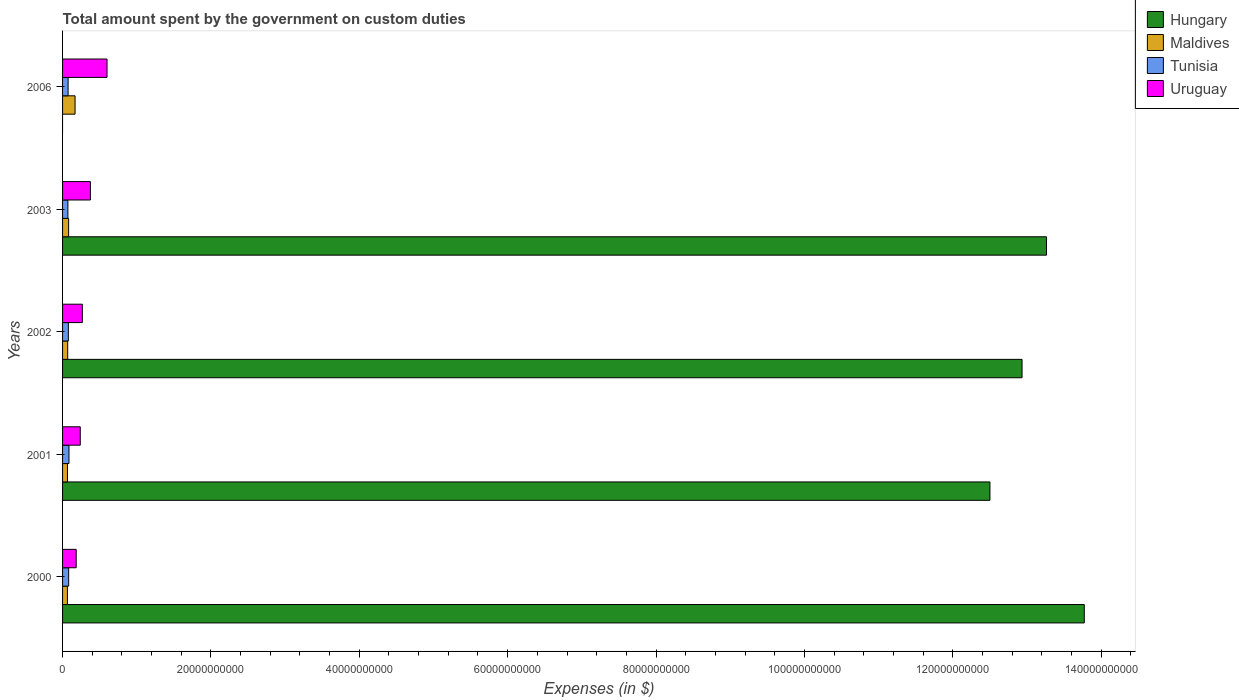How many groups of bars are there?
Keep it short and to the point. 5. How many bars are there on the 3rd tick from the top?
Ensure brevity in your answer.  4. How many bars are there on the 5th tick from the bottom?
Keep it short and to the point. 3. What is the amount spent on custom duties by the government in Hungary in 2000?
Your response must be concise. 1.38e+11. Across all years, what is the maximum amount spent on custom duties by the government in Uruguay?
Make the answer very short. 5.99e+09. Across all years, what is the minimum amount spent on custom duties by the government in Tunisia?
Make the answer very short. 7.17e+08. What is the total amount spent on custom duties by the government in Maldives in the graph?
Make the answer very short. 4.51e+09. What is the difference between the amount spent on custom duties by the government in Hungary in 2000 and that in 2002?
Your answer should be compact. 8.39e+09. What is the difference between the amount spent on custom duties by the government in Hungary in 2001 and the amount spent on custom duties by the government in Tunisia in 2002?
Make the answer very short. 1.24e+11. What is the average amount spent on custom duties by the government in Hungary per year?
Provide a succinct answer. 1.05e+11. In the year 2002, what is the difference between the amount spent on custom duties by the government in Hungary and amount spent on custom duties by the government in Maldives?
Make the answer very short. 1.29e+11. In how many years, is the amount spent on custom duties by the government in Hungary greater than 104000000000 $?
Offer a very short reply. 4. What is the ratio of the amount spent on custom duties by the government in Uruguay in 2001 to that in 2006?
Offer a terse response. 0.4. Is the amount spent on custom duties by the government in Hungary in 2000 less than that in 2003?
Your answer should be very brief. No. What is the difference between the highest and the second highest amount spent on custom duties by the government in Maldives?
Your answer should be very brief. 8.67e+08. What is the difference between the highest and the lowest amount spent on custom duties by the government in Hungary?
Offer a terse response. 1.38e+11. In how many years, is the amount spent on custom duties by the government in Maldives greater than the average amount spent on custom duties by the government in Maldives taken over all years?
Provide a succinct answer. 1. Is it the case that in every year, the sum of the amount spent on custom duties by the government in Maldives and amount spent on custom duties by the government in Uruguay is greater than the amount spent on custom duties by the government in Hungary?
Your response must be concise. No. How many bars are there?
Keep it short and to the point. 19. How many years are there in the graph?
Make the answer very short. 5. What is the title of the graph?
Offer a terse response. Total amount spent by the government on custom duties. Does "Caribbean small states" appear as one of the legend labels in the graph?
Give a very brief answer. No. What is the label or title of the X-axis?
Give a very brief answer. Expenses (in $). What is the label or title of the Y-axis?
Offer a terse response. Years. What is the Expenses (in $) of Hungary in 2000?
Provide a short and direct response. 1.38e+11. What is the Expenses (in $) of Maldives in 2000?
Your answer should be very brief. 6.53e+08. What is the Expenses (in $) of Tunisia in 2000?
Provide a short and direct response. 8.22e+08. What is the Expenses (in $) in Uruguay in 2000?
Give a very brief answer. 1.84e+09. What is the Expenses (in $) in Hungary in 2001?
Provide a succinct answer. 1.25e+11. What is the Expenses (in $) of Maldives in 2001?
Offer a terse response. 6.62e+08. What is the Expenses (in $) of Tunisia in 2001?
Offer a terse response. 8.66e+08. What is the Expenses (in $) in Uruguay in 2001?
Provide a short and direct response. 2.38e+09. What is the Expenses (in $) in Hungary in 2002?
Make the answer very short. 1.29e+11. What is the Expenses (in $) of Maldives in 2002?
Give a very brief answer. 6.92e+08. What is the Expenses (in $) in Tunisia in 2002?
Ensure brevity in your answer.  7.81e+08. What is the Expenses (in $) of Uruguay in 2002?
Your answer should be compact. 2.67e+09. What is the Expenses (in $) in Hungary in 2003?
Offer a terse response. 1.33e+11. What is the Expenses (in $) in Maldives in 2003?
Provide a short and direct response. 8.17e+08. What is the Expenses (in $) in Tunisia in 2003?
Provide a succinct answer. 7.17e+08. What is the Expenses (in $) in Uruguay in 2003?
Give a very brief answer. 3.75e+09. What is the Expenses (in $) in Maldives in 2006?
Your answer should be compact. 1.68e+09. What is the Expenses (in $) in Tunisia in 2006?
Your answer should be compact. 7.47e+08. What is the Expenses (in $) in Uruguay in 2006?
Provide a succinct answer. 5.99e+09. Across all years, what is the maximum Expenses (in $) of Hungary?
Your answer should be compact. 1.38e+11. Across all years, what is the maximum Expenses (in $) in Maldives?
Ensure brevity in your answer.  1.68e+09. Across all years, what is the maximum Expenses (in $) of Tunisia?
Provide a short and direct response. 8.66e+08. Across all years, what is the maximum Expenses (in $) of Uruguay?
Your answer should be compact. 5.99e+09. Across all years, what is the minimum Expenses (in $) of Maldives?
Ensure brevity in your answer.  6.53e+08. Across all years, what is the minimum Expenses (in $) in Tunisia?
Keep it short and to the point. 7.17e+08. Across all years, what is the minimum Expenses (in $) of Uruguay?
Your answer should be very brief. 1.84e+09. What is the total Expenses (in $) in Hungary in the graph?
Your answer should be compact. 5.25e+11. What is the total Expenses (in $) in Maldives in the graph?
Your answer should be very brief. 4.51e+09. What is the total Expenses (in $) of Tunisia in the graph?
Give a very brief answer. 3.93e+09. What is the total Expenses (in $) in Uruguay in the graph?
Your response must be concise. 1.66e+1. What is the difference between the Expenses (in $) in Hungary in 2000 and that in 2001?
Ensure brevity in your answer.  1.27e+1. What is the difference between the Expenses (in $) in Maldives in 2000 and that in 2001?
Give a very brief answer. -9.10e+06. What is the difference between the Expenses (in $) of Tunisia in 2000 and that in 2001?
Offer a very short reply. -4.38e+07. What is the difference between the Expenses (in $) of Uruguay in 2000 and that in 2001?
Make the answer very short. -5.47e+08. What is the difference between the Expenses (in $) in Hungary in 2000 and that in 2002?
Provide a succinct answer. 8.39e+09. What is the difference between the Expenses (in $) in Maldives in 2000 and that in 2002?
Offer a terse response. -3.95e+07. What is the difference between the Expenses (in $) in Tunisia in 2000 and that in 2002?
Ensure brevity in your answer.  4.11e+07. What is the difference between the Expenses (in $) in Uruguay in 2000 and that in 2002?
Offer a terse response. -8.29e+08. What is the difference between the Expenses (in $) in Hungary in 2000 and that in 2003?
Offer a very short reply. 5.09e+09. What is the difference between the Expenses (in $) of Maldives in 2000 and that in 2003?
Offer a terse response. -1.64e+08. What is the difference between the Expenses (in $) in Tunisia in 2000 and that in 2003?
Provide a succinct answer. 1.05e+08. What is the difference between the Expenses (in $) in Uruguay in 2000 and that in 2003?
Offer a very short reply. -1.92e+09. What is the difference between the Expenses (in $) in Maldives in 2000 and that in 2006?
Your answer should be very brief. -1.03e+09. What is the difference between the Expenses (in $) of Tunisia in 2000 and that in 2006?
Give a very brief answer. 7.54e+07. What is the difference between the Expenses (in $) in Uruguay in 2000 and that in 2006?
Offer a very short reply. -4.16e+09. What is the difference between the Expenses (in $) of Hungary in 2001 and that in 2002?
Offer a very short reply. -4.33e+09. What is the difference between the Expenses (in $) in Maldives in 2001 and that in 2002?
Your answer should be compact. -3.04e+07. What is the difference between the Expenses (in $) of Tunisia in 2001 and that in 2002?
Your response must be concise. 8.49e+07. What is the difference between the Expenses (in $) of Uruguay in 2001 and that in 2002?
Ensure brevity in your answer.  -2.82e+08. What is the difference between the Expenses (in $) of Hungary in 2001 and that in 2003?
Make the answer very short. -7.62e+09. What is the difference between the Expenses (in $) of Maldives in 2001 and that in 2003?
Offer a very short reply. -1.55e+08. What is the difference between the Expenses (in $) of Tunisia in 2001 and that in 2003?
Offer a terse response. 1.49e+08. What is the difference between the Expenses (in $) in Uruguay in 2001 and that in 2003?
Offer a very short reply. -1.37e+09. What is the difference between the Expenses (in $) in Maldives in 2001 and that in 2006?
Your response must be concise. -1.02e+09. What is the difference between the Expenses (in $) of Tunisia in 2001 and that in 2006?
Provide a short and direct response. 1.19e+08. What is the difference between the Expenses (in $) in Uruguay in 2001 and that in 2006?
Offer a terse response. -3.61e+09. What is the difference between the Expenses (in $) of Hungary in 2002 and that in 2003?
Your answer should be compact. -3.30e+09. What is the difference between the Expenses (in $) of Maldives in 2002 and that in 2003?
Give a very brief answer. -1.25e+08. What is the difference between the Expenses (in $) of Tunisia in 2002 and that in 2003?
Provide a short and direct response. 6.41e+07. What is the difference between the Expenses (in $) of Uruguay in 2002 and that in 2003?
Ensure brevity in your answer.  -1.09e+09. What is the difference between the Expenses (in $) of Maldives in 2002 and that in 2006?
Your answer should be compact. -9.92e+08. What is the difference between the Expenses (in $) in Tunisia in 2002 and that in 2006?
Your answer should be very brief. 3.43e+07. What is the difference between the Expenses (in $) of Uruguay in 2002 and that in 2006?
Offer a very short reply. -3.33e+09. What is the difference between the Expenses (in $) in Maldives in 2003 and that in 2006?
Provide a short and direct response. -8.67e+08. What is the difference between the Expenses (in $) in Tunisia in 2003 and that in 2006?
Ensure brevity in your answer.  -2.98e+07. What is the difference between the Expenses (in $) of Uruguay in 2003 and that in 2006?
Provide a succinct answer. -2.24e+09. What is the difference between the Expenses (in $) of Hungary in 2000 and the Expenses (in $) of Maldives in 2001?
Provide a succinct answer. 1.37e+11. What is the difference between the Expenses (in $) in Hungary in 2000 and the Expenses (in $) in Tunisia in 2001?
Give a very brief answer. 1.37e+11. What is the difference between the Expenses (in $) in Hungary in 2000 and the Expenses (in $) in Uruguay in 2001?
Offer a terse response. 1.35e+11. What is the difference between the Expenses (in $) of Maldives in 2000 and the Expenses (in $) of Tunisia in 2001?
Keep it short and to the point. -2.14e+08. What is the difference between the Expenses (in $) of Maldives in 2000 and the Expenses (in $) of Uruguay in 2001?
Your answer should be very brief. -1.73e+09. What is the difference between the Expenses (in $) of Tunisia in 2000 and the Expenses (in $) of Uruguay in 2001?
Offer a very short reply. -1.56e+09. What is the difference between the Expenses (in $) of Hungary in 2000 and the Expenses (in $) of Maldives in 2002?
Your answer should be compact. 1.37e+11. What is the difference between the Expenses (in $) of Hungary in 2000 and the Expenses (in $) of Tunisia in 2002?
Your answer should be compact. 1.37e+11. What is the difference between the Expenses (in $) of Hungary in 2000 and the Expenses (in $) of Uruguay in 2002?
Offer a terse response. 1.35e+11. What is the difference between the Expenses (in $) of Maldives in 2000 and the Expenses (in $) of Tunisia in 2002?
Offer a very short reply. -1.29e+08. What is the difference between the Expenses (in $) in Maldives in 2000 and the Expenses (in $) in Uruguay in 2002?
Offer a terse response. -2.01e+09. What is the difference between the Expenses (in $) in Tunisia in 2000 and the Expenses (in $) in Uruguay in 2002?
Provide a short and direct response. -1.84e+09. What is the difference between the Expenses (in $) in Hungary in 2000 and the Expenses (in $) in Maldives in 2003?
Your answer should be very brief. 1.37e+11. What is the difference between the Expenses (in $) in Hungary in 2000 and the Expenses (in $) in Tunisia in 2003?
Your answer should be compact. 1.37e+11. What is the difference between the Expenses (in $) in Hungary in 2000 and the Expenses (in $) in Uruguay in 2003?
Provide a short and direct response. 1.34e+11. What is the difference between the Expenses (in $) of Maldives in 2000 and the Expenses (in $) of Tunisia in 2003?
Give a very brief answer. -6.46e+07. What is the difference between the Expenses (in $) in Maldives in 2000 and the Expenses (in $) in Uruguay in 2003?
Your answer should be compact. -3.10e+09. What is the difference between the Expenses (in $) in Tunisia in 2000 and the Expenses (in $) in Uruguay in 2003?
Give a very brief answer. -2.93e+09. What is the difference between the Expenses (in $) of Hungary in 2000 and the Expenses (in $) of Maldives in 2006?
Your answer should be very brief. 1.36e+11. What is the difference between the Expenses (in $) in Hungary in 2000 and the Expenses (in $) in Tunisia in 2006?
Your answer should be very brief. 1.37e+11. What is the difference between the Expenses (in $) in Hungary in 2000 and the Expenses (in $) in Uruguay in 2006?
Make the answer very short. 1.32e+11. What is the difference between the Expenses (in $) of Maldives in 2000 and the Expenses (in $) of Tunisia in 2006?
Give a very brief answer. -9.44e+07. What is the difference between the Expenses (in $) of Maldives in 2000 and the Expenses (in $) of Uruguay in 2006?
Make the answer very short. -5.34e+09. What is the difference between the Expenses (in $) in Tunisia in 2000 and the Expenses (in $) in Uruguay in 2006?
Your response must be concise. -5.17e+09. What is the difference between the Expenses (in $) of Hungary in 2001 and the Expenses (in $) of Maldives in 2002?
Your answer should be very brief. 1.24e+11. What is the difference between the Expenses (in $) of Hungary in 2001 and the Expenses (in $) of Tunisia in 2002?
Give a very brief answer. 1.24e+11. What is the difference between the Expenses (in $) of Hungary in 2001 and the Expenses (in $) of Uruguay in 2002?
Ensure brevity in your answer.  1.22e+11. What is the difference between the Expenses (in $) in Maldives in 2001 and the Expenses (in $) in Tunisia in 2002?
Your answer should be compact. -1.20e+08. What is the difference between the Expenses (in $) in Maldives in 2001 and the Expenses (in $) in Uruguay in 2002?
Your response must be concise. -2.01e+09. What is the difference between the Expenses (in $) of Tunisia in 2001 and the Expenses (in $) of Uruguay in 2002?
Your response must be concise. -1.80e+09. What is the difference between the Expenses (in $) of Hungary in 2001 and the Expenses (in $) of Maldives in 2003?
Provide a succinct answer. 1.24e+11. What is the difference between the Expenses (in $) of Hungary in 2001 and the Expenses (in $) of Tunisia in 2003?
Provide a succinct answer. 1.24e+11. What is the difference between the Expenses (in $) of Hungary in 2001 and the Expenses (in $) of Uruguay in 2003?
Keep it short and to the point. 1.21e+11. What is the difference between the Expenses (in $) of Maldives in 2001 and the Expenses (in $) of Tunisia in 2003?
Provide a short and direct response. -5.55e+07. What is the difference between the Expenses (in $) of Maldives in 2001 and the Expenses (in $) of Uruguay in 2003?
Your answer should be compact. -3.09e+09. What is the difference between the Expenses (in $) in Tunisia in 2001 and the Expenses (in $) in Uruguay in 2003?
Keep it short and to the point. -2.89e+09. What is the difference between the Expenses (in $) in Hungary in 2001 and the Expenses (in $) in Maldives in 2006?
Give a very brief answer. 1.23e+11. What is the difference between the Expenses (in $) in Hungary in 2001 and the Expenses (in $) in Tunisia in 2006?
Keep it short and to the point. 1.24e+11. What is the difference between the Expenses (in $) in Hungary in 2001 and the Expenses (in $) in Uruguay in 2006?
Offer a very short reply. 1.19e+11. What is the difference between the Expenses (in $) in Maldives in 2001 and the Expenses (in $) in Tunisia in 2006?
Offer a terse response. -8.53e+07. What is the difference between the Expenses (in $) of Maldives in 2001 and the Expenses (in $) of Uruguay in 2006?
Provide a succinct answer. -5.33e+09. What is the difference between the Expenses (in $) of Tunisia in 2001 and the Expenses (in $) of Uruguay in 2006?
Make the answer very short. -5.13e+09. What is the difference between the Expenses (in $) of Hungary in 2002 and the Expenses (in $) of Maldives in 2003?
Offer a very short reply. 1.29e+11. What is the difference between the Expenses (in $) in Hungary in 2002 and the Expenses (in $) in Tunisia in 2003?
Give a very brief answer. 1.29e+11. What is the difference between the Expenses (in $) in Hungary in 2002 and the Expenses (in $) in Uruguay in 2003?
Give a very brief answer. 1.26e+11. What is the difference between the Expenses (in $) in Maldives in 2002 and the Expenses (in $) in Tunisia in 2003?
Ensure brevity in your answer.  -2.51e+07. What is the difference between the Expenses (in $) in Maldives in 2002 and the Expenses (in $) in Uruguay in 2003?
Offer a terse response. -3.06e+09. What is the difference between the Expenses (in $) of Tunisia in 2002 and the Expenses (in $) of Uruguay in 2003?
Your response must be concise. -2.97e+09. What is the difference between the Expenses (in $) in Hungary in 2002 and the Expenses (in $) in Maldives in 2006?
Your response must be concise. 1.28e+11. What is the difference between the Expenses (in $) of Hungary in 2002 and the Expenses (in $) of Tunisia in 2006?
Give a very brief answer. 1.29e+11. What is the difference between the Expenses (in $) in Hungary in 2002 and the Expenses (in $) in Uruguay in 2006?
Your answer should be very brief. 1.23e+11. What is the difference between the Expenses (in $) in Maldives in 2002 and the Expenses (in $) in Tunisia in 2006?
Make the answer very short. -5.49e+07. What is the difference between the Expenses (in $) of Maldives in 2002 and the Expenses (in $) of Uruguay in 2006?
Your answer should be compact. -5.30e+09. What is the difference between the Expenses (in $) of Tunisia in 2002 and the Expenses (in $) of Uruguay in 2006?
Your answer should be very brief. -5.21e+09. What is the difference between the Expenses (in $) of Hungary in 2003 and the Expenses (in $) of Maldives in 2006?
Give a very brief answer. 1.31e+11. What is the difference between the Expenses (in $) in Hungary in 2003 and the Expenses (in $) in Tunisia in 2006?
Your response must be concise. 1.32e+11. What is the difference between the Expenses (in $) in Hungary in 2003 and the Expenses (in $) in Uruguay in 2006?
Give a very brief answer. 1.27e+11. What is the difference between the Expenses (in $) of Maldives in 2003 and the Expenses (in $) of Tunisia in 2006?
Provide a short and direct response. 7.01e+07. What is the difference between the Expenses (in $) of Maldives in 2003 and the Expenses (in $) of Uruguay in 2006?
Offer a very short reply. -5.18e+09. What is the difference between the Expenses (in $) of Tunisia in 2003 and the Expenses (in $) of Uruguay in 2006?
Your response must be concise. -5.28e+09. What is the average Expenses (in $) of Hungary per year?
Your answer should be very brief. 1.05e+11. What is the average Expenses (in $) of Maldives per year?
Provide a succinct answer. 9.02e+08. What is the average Expenses (in $) in Tunisia per year?
Your answer should be compact. 7.87e+08. What is the average Expenses (in $) in Uruguay per year?
Your answer should be compact. 3.33e+09. In the year 2000, what is the difference between the Expenses (in $) in Hungary and Expenses (in $) in Maldives?
Offer a very short reply. 1.37e+11. In the year 2000, what is the difference between the Expenses (in $) in Hungary and Expenses (in $) in Tunisia?
Give a very brief answer. 1.37e+11. In the year 2000, what is the difference between the Expenses (in $) in Hungary and Expenses (in $) in Uruguay?
Keep it short and to the point. 1.36e+11. In the year 2000, what is the difference between the Expenses (in $) of Maldives and Expenses (in $) of Tunisia?
Offer a terse response. -1.70e+08. In the year 2000, what is the difference between the Expenses (in $) in Maldives and Expenses (in $) in Uruguay?
Your response must be concise. -1.19e+09. In the year 2000, what is the difference between the Expenses (in $) in Tunisia and Expenses (in $) in Uruguay?
Keep it short and to the point. -1.02e+09. In the year 2001, what is the difference between the Expenses (in $) of Hungary and Expenses (in $) of Maldives?
Offer a terse response. 1.24e+11. In the year 2001, what is the difference between the Expenses (in $) of Hungary and Expenses (in $) of Tunisia?
Keep it short and to the point. 1.24e+11. In the year 2001, what is the difference between the Expenses (in $) of Hungary and Expenses (in $) of Uruguay?
Your answer should be very brief. 1.23e+11. In the year 2001, what is the difference between the Expenses (in $) of Maldives and Expenses (in $) of Tunisia?
Provide a short and direct response. -2.04e+08. In the year 2001, what is the difference between the Expenses (in $) of Maldives and Expenses (in $) of Uruguay?
Your answer should be compact. -1.72e+09. In the year 2001, what is the difference between the Expenses (in $) in Tunisia and Expenses (in $) in Uruguay?
Your answer should be compact. -1.52e+09. In the year 2002, what is the difference between the Expenses (in $) in Hungary and Expenses (in $) in Maldives?
Your answer should be very brief. 1.29e+11. In the year 2002, what is the difference between the Expenses (in $) of Hungary and Expenses (in $) of Tunisia?
Your answer should be very brief. 1.29e+11. In the year 2002, what is the difference between the Expenses (in $) in Hungary and Expenses (in $) in Uruguay?
Your answer should be very brief. 1.27e+11. In the year 2002, what is the difference between the Expenses (in $) in Maldives and Expenses (in $) in Tunisia?
Offer a terse response. -8.92e+07. In the year 2002, what is the difference between the Expenses (in $) of Maldives and Expenses (in $) of Uruguay?
Your answer should be compact. -1.98e+09. In the year 2002, what is the difference between the Expenses (in $) of Tunisia and Expenses (in $) of Uruguay?
Your answer should be very brief. -1.89e+09. In the year 2003, what is the difference between the Expenses (in $) in Hungary and Expenses (in $) in Maldives?
Keep it short and to the point. 1.32e+11. In the year 2003, what is the difference between the Expenses (in $) in Hungary and Expenses (in $) in Tunisia?
Your answer should be very brief. 1.32e+11. In the year 2003, what is the difference between the Expenses (in $) in Hungary and Expenses (in $) in Uruguay?
Your answer should be compact. 1.29e+11. In the year 2003, what is the difference between the Expenses (in $) of Maldives and Expenses (in $) of Tunisia?
Provide a succinct answer. 9.99e+07. In the year 2003, what is the difference between the Expenses (in $) in Maldives and Expenses (in $) in Uruguay?
Provide a short and direct response. -2.94e+09. In the year 2003, what is the difference between the Expenses (in $) in Tunisia and Expenses (in $) in Uruguay?
Your answer should be very brief. -3.04e+09. In the year 2006, what is the difference between the Expenses (in $) in Maldives and Expenses (in $) in Tunisia?
Make the answer very short. 9.37e+08. In the year 2006, what is the difference between the Expenses (in $) of Maldives and Expenses (in $) of Uruguay?
Make the answer very short. -4.31e+09. In the year 2006, what is the difference between the Expenses (in $) in Tunisia and Expenses (in $) in Uruguay?
Your response must be concise. -5.25e+09. What is the ratio of the Expenses (in $) in Hungary in 2000 to that in 2001?
Give a very brief answer. 1.1. What is the ratio of the Expenses (in $) of Maldives in 2000 to that in 2001?
Your response must be concise. 0.99. What is the ratio of the Expenses (in $) in Tunisia in 2000 to that in 2001?
Make the answer very short. 0.95. What is the ratio of the Expenses (in $) in Uruguay in 2000 to that in 2001?
Ensure brevity in your answer.  0.77. What is the ratio of the Expenses (in $) in Hungary in 2000 to that in 2002?
Offer a very short reply. 1.06. What is the ratio of the Expenses (in $) in Maldives in 2000 to that in 2002?
Offer a very short reply. 0.94. What is the ratio of the Expenses (in $) of Tunisia in 2000 to that in 2002?
Your answer should be very brief. 1.05. What is the ratio of the Expenses (in $) of Uruguay in 2000 to that in 2002?
Offer a very short reply. 0.69. What is the ratio of the Expenses (in $) of Hungary in 2000 to that in 2003?
Provide a succinct answer. 1.04. What is the ratio of the Expenses (in $) of Maldives in 2000 to that in 2003?
Ensure brevity in your answer.  0.8. What is the ratio of the Expenses (in $) in Tunisia in 2000 to that in 2003?
Your answer should be compact. 1.15. What is the ratio of the Expenses (in $) of Uruguay in 2000 to that in 2003?
Give a very brief answer. 0.49. What is the ratio of the Expenses (in $) of Maldives in 2000 to that in 2006?
Provide a short and direct response. 0.39. What is the ratio of the Expenses (in $) of Tunisia in 2000 to that in 2006?
Offer a very short reply. 1.1. What is the ratio of the Expenses (in $) of Uruguay in 2000 to that in 2006?
Make the answer very short. 0.31. What is the ratio of the Expenses (in $) of Hungary in 2001 to that in 2002?
Make the answer very short. 0.97. What is the ratio of the Expenses (in $) of Maldives in 2001 to that in 2002?
Offer a very short reply. 0.96. What is the ratio of the Expenses (in $) in Tunisia in 2001 to that in 2002?
Give a very brief answer. 1.11. What is the ratio of the Expenses (in $) of Uruguay in 2001 to that in 2002?
Your answer should be very brief. 0.89. What is the ratio of the Expenses (in $) in Hungary in 2001 to that in 2003?
Provide a succinct answer. 0.94. What is the ratio of the Expenses (in $) of Maldives in 2001 to that in 2003?
Your answer should be compact. 0.81. What is the ratio of the Expenses (in $) of Tunisia in 2001 to that in 2003?
Offer a terse response. 1.21. What is the ratio of the Expenses (in $) in Uruguay in 2001 to that in 2003?
Give a very brief answer. 0.64. What is the ratio of the Expenses (in $) of Maldives in 2001 to that in 2006?
Give a very brief answer. 0.39. What is the ratio of the Expenses (in $) in Tunisia in 2001 to that in 2006?
Provide a succinct answer. 1.16. What is the ratio of the Expenses (in $) in Uruguay in 2001 to that in 2006?
Offer a terse response. 0.4. What is the ratio of the Expenses (in $) in Hungary in 2002 to that in 2003?
Provide a short and direct response. 0.98. What is the ratio of the Expenses (in $) of Maldives in 2002 to that in 2003?
Give a very brief answer. 0.85. What is the ratio of the Expenses (in $) of Tunisia in 2002 to that in 2003?
Your answer should be compact. 1.09. What is the ratio of the Expenses (in $) of Uruguay in 2002 to that in 2003?
Your answer should be compact. 0.71. What is the ratio of the Expenses (in $) in Maldives in 2002 to that in 2006?
Keep it short and to the point. 0.41. What is the ratio of the Expenses (in $) of Tunisia in 2002 to that in 2006?
Offer a very short reply. 1.05. What is the ratio of the Expenses (in $) in Uruguay in 2002 to that in 2006?
Your answer should be very brief. 0.44. What is the ratio of the Expenses (in $) in Maldives in 2003 to that in 2006?
Offer a very short reply. 0.49. What is the ratio of the Expenses (in $) in Tunisia in 2003 to that in 2006?
Your answer should be compact. 0.96. What is the ratio of the Expenses (in $) of Uruguay in 2003 to that in 2006?
Your answer should be very brief. 0.63. What is the difference between the highest and the second highest Expenses (in $) of Hungary?
Your response must be concise. 5.09e+09. What is the difference between the highest and the second highest Expenses (in $) of Maldives?
Keep it short and to the point. 8.67e+08. What is the difference between the highest and the second highest Expenses (in $) of Tunisia?
Provide a succinct answer. 4.38e+07. What is the difference between the highest and the second highest Expenses (in $) in Uruguay?
Provide a short and direct response. 2.24e+09. What is the difference between the highest and the lowest Expenses (in $) in Hungary?
Make the answer very short. 1.38e+11. What is the difference between the highest and the lowest Expenses (in $) of Maldives?
Make the answer very short. 1.03e+09. What is the difference between the highest and the lowest Expenses (in $) in Tunisia?
Offer a terse response. 1.49e+08. What is the difference between the highest and the lowest Expenses (in $) in Uruguay?
Keep it short and to the point. 4.16e+09. 